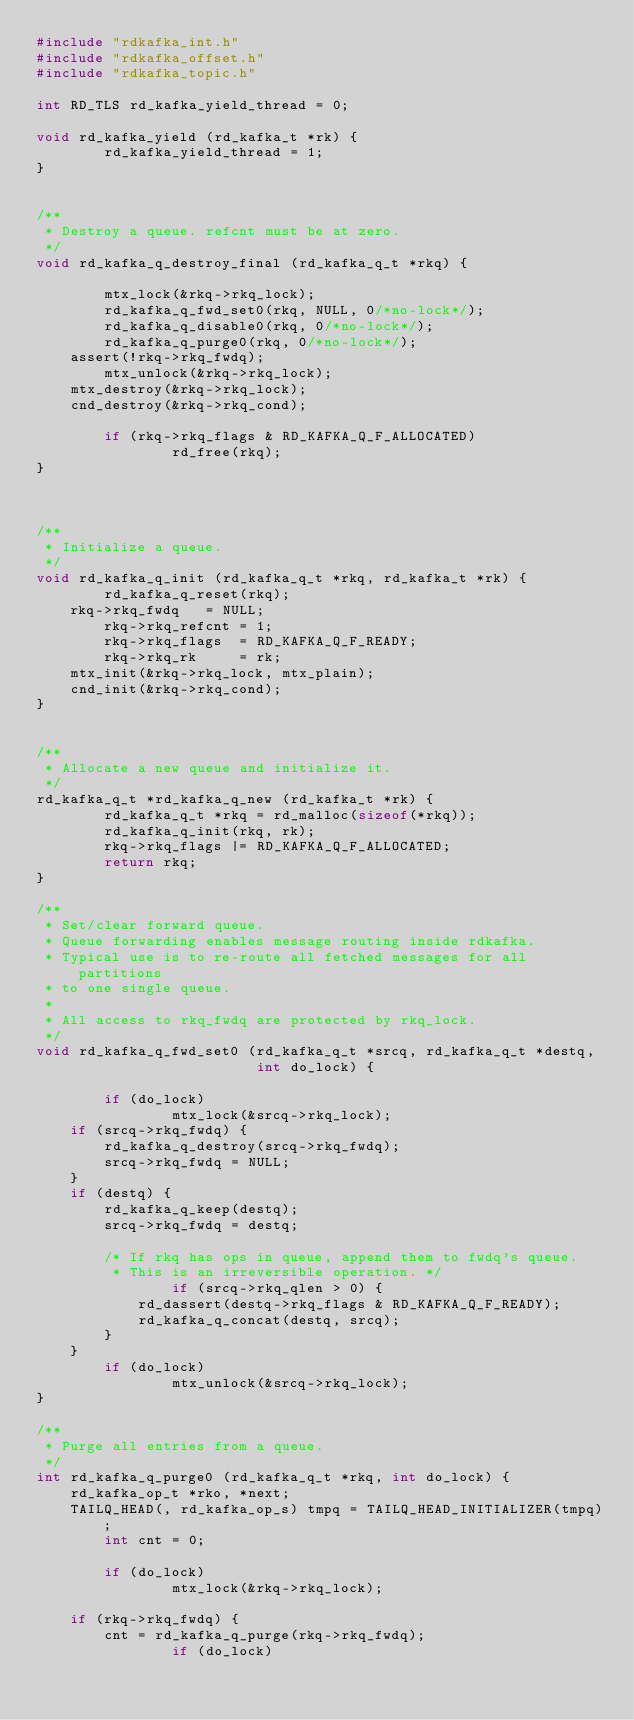Convert code to text. <code><loc_0><loc_0><loc_500><loc_500><_C_>#include "rdkafka_int.h"
#include "rdkafka_offset.h"
#include "rdkafka_topic.h"

int RD_TLS rd_kafka_yield_thread = 0;

void rd_kafka_yield (rd_kafka_t *rk) {
        rd_kafka_yield_thread = 1;
}


/**
 * Destroy a queue. refcnt must be at zero.
 */
void rd_kafka_q_destroy_final (rd_kafka_q_t *rkq) {

        mtx_lock(&rkq->rkq_lock);
        rd_kafka_q_fwd_set0(rkq, NULL, 0/*no-lock*/);
        rd_kafka_q_disable0(rkq, 0/*no-lock*/);
        rd_kafka_q_purge0(rkq, 0/*no-lock*/);
	assert(!rkq->rkq_fwdq);
        mtx_unlock(&rkq->rkq_lock);
	mtx_destroy(&rkq->rkq_lock);
	cnd_destroy(&rkq->rkq_cond);

        if (rkq->rkq_flags & RD_KAFKA_Q_F_ALLOCATED)
                rd_free(rkq);
}



/**
 * Initialize a queue.
 */
void rd_kafka_q_init (rd_kafka_q_t *rkq, rd_kafka_t *rk) {
        rd_kafka_q_reset(rkq);
	rkq->rkq_fwdq   = NULL;
        rkq->rkq_refcnt = 1;
        rkq->rkq_flags  = RD_KAFKA_Q_F_READY;
        rkq->rkq_rk     = rk;
	mtx_init(&rkq->rkq_lock, mtx_plain);
	cnd_init(&rkq->rkq_cond);
}


/**
 * Allocate a new queue and initialize it.
 */
rd_kafka_q_t *rd_kafka_q_new (rd_kafka_t *rk) {
        rd_kafka_q_t *rkq = rd_malloc(sizeof(*rkq));
        rd_kafka_q_init(rkq, rk);
        rkq->rkq_flags |= RD_KAFKA_Q_F_ALLOCATED;
        return rkq;
}

/**
 * Set/clear forward queue.
 * Queue forwarding enables message routing inside rdkafka.
 * Typical use is to re-route all fetched messages for all partitions
 * to one single queue.
 *
 * All access to rkq_fwdq are protected by rkq_lock.
 */
void rd_kafka_q_fwd_set0 (rd_kafka_q_t *srcq, rd_kafka_q_t *destq,
                          int do_lock) {

        if (do_lock)
                mtx_lock(&srcq->rkq_lock);
	if (srcq->rkq_fwdq) {
		rd_kafka_q_destroy(srcq->rkq_fwdq);
		srcq->rkq_fwdq = NULL;
	}
	if (destq) {
		rd_kafka_q_keep(destq);
		srcq->rkq_fwdq = destq;

		/* If rkq has ops in queue, append them to fwdq's queue.
		 * This is an irreversible operation. */
                if (srcq->rkq_qlen > 0) {
			rd_dassert(destq->rkq_flags & RD_KAFKA_Q_F_READY);
			rd_kafka_q_concat(destq, srcq);
		}
	}
        if (do_lock)
                mtx_unlock(&srcq->rkq_lock);
}

/**
 * Purge all entries from a queue.
 */
int rd_kafka_q_purge0 (rd_kafka_q_t *rkq, int do_lock) {
	rd_kafka_op_t *rko, *next;
	TAILQ_HEAD(, rd_kafka_op_s) tmpq = TAILQ_HEAD_INITIALIZER(tmpq);
        int cnt = 0;

        if (do_lock)
                mtx_lock(&rkq->rkq_lock);

	if (rkq->rkq_fwdq) {
		cnt = rd_kafka_q_purge(rkq->rkq_fwdq);
                if (do_lock)</code> 